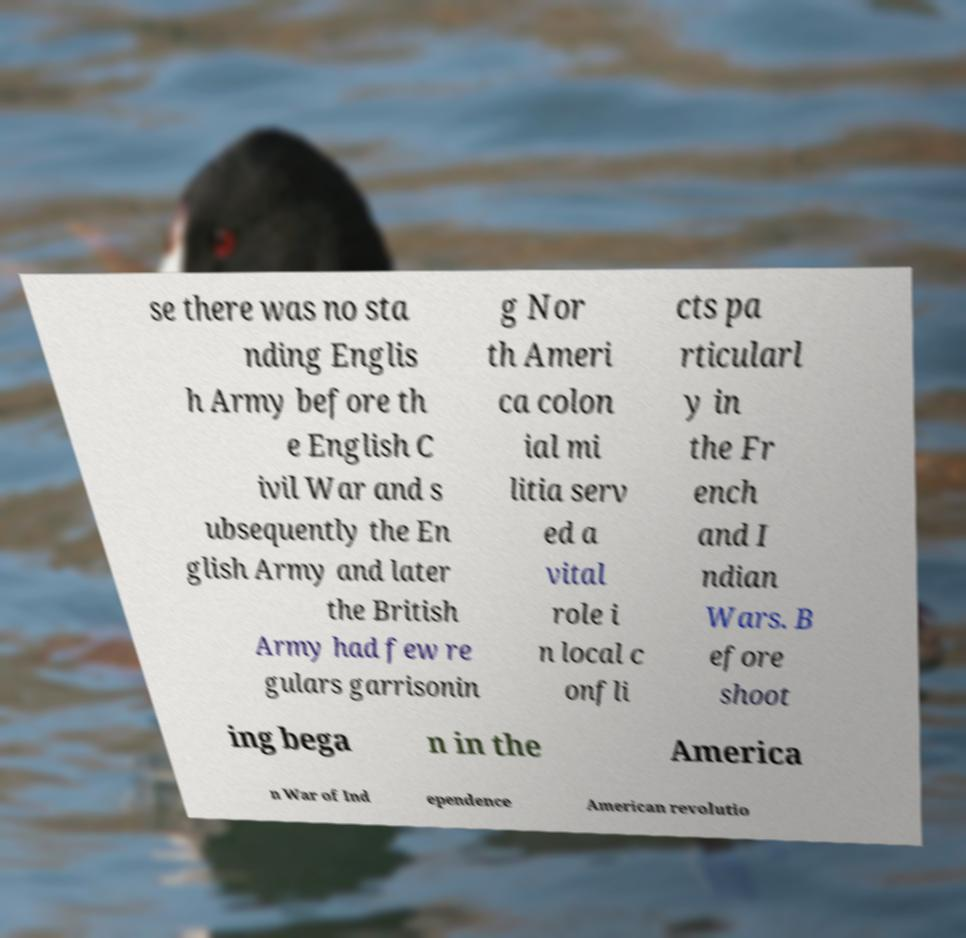Please identify and transcribe the text found in this image. se there was no sta nding Englis h Army before th e English C ivil War and s ubsequently the En glish Army and later the British Army had few re gulars garrisonin g Nor th Ameri ca colon ial mi litia serv ed a vital role i n local c onfli cts pa rticularl y in the Fr ench and I ndian Wars. B efore shoot ing bega n in the America n War of Ind ependence American revolutio 